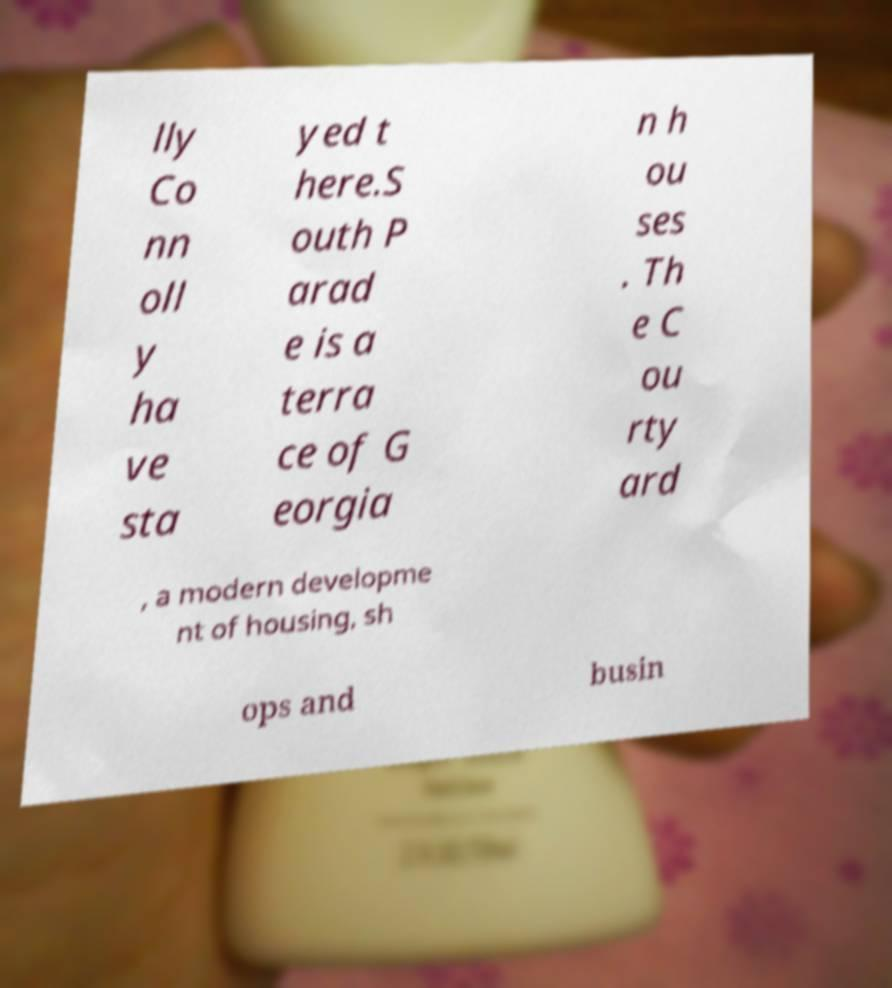Could you extract and type out the text from this image? lly Co nn oll y ha ve sta yed t here.S outh P arad e is a terra ce of G eorgia n h ou ses . Th e C ou rty ard , a modern developme nt of housing, sh ops and busin 